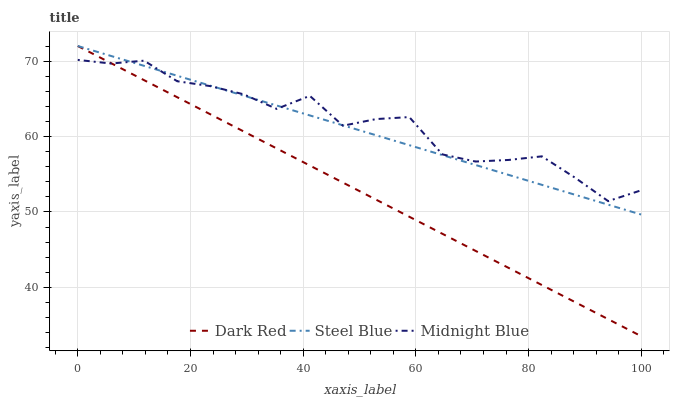Does Dark Red have the minimum area under the curve?
Answer yes or no. Yes. Does Midnight Blue have the maximum area under the curve?
Answer yes or no. Yes. Does Steel Blue have the minimum area under the curve?
Answer yes or no. No. Does Steel Blue have the maximum area under the curve?
Answer yes or no. No. Is Dark Red the smoothest?
Answer yes or no. Yes. Is Midnight Blue the roughest?
Answer yes or no. Yes. Is Steel Blue the smoothest?
Answer yes or no. No. Is Steel Blue the roughest?
Answer yes or no. No. Does Dark Red have the lowest value?
Answer yes or no. Yes. Does Steel Blue have the lowest value?
Answer yes or no. No. Does Steel Blue have the highest value?
Answer yes or no. Yes. Does Midnight Blue have the highest value?
Answer yes or no. No. Does Dark Red intersect Midnight Blue?
Answer yes or no. Yes. Is Dark Red less than Midnight Blue?
Answer yes or no. No. Is Dark Red greater than Midnight Blue?
Answer yes or no. No. 